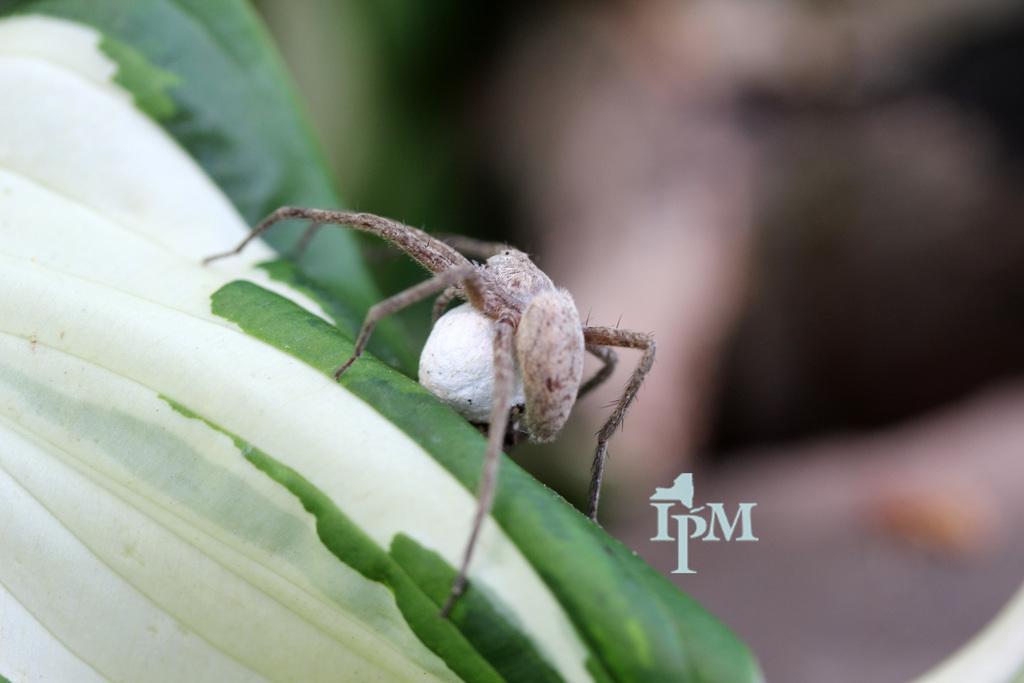Could you give a brief overview of what you see in this image? We can see an insect on a leaf. In the background the image is blur and at the bottom there is a text written on the image. 